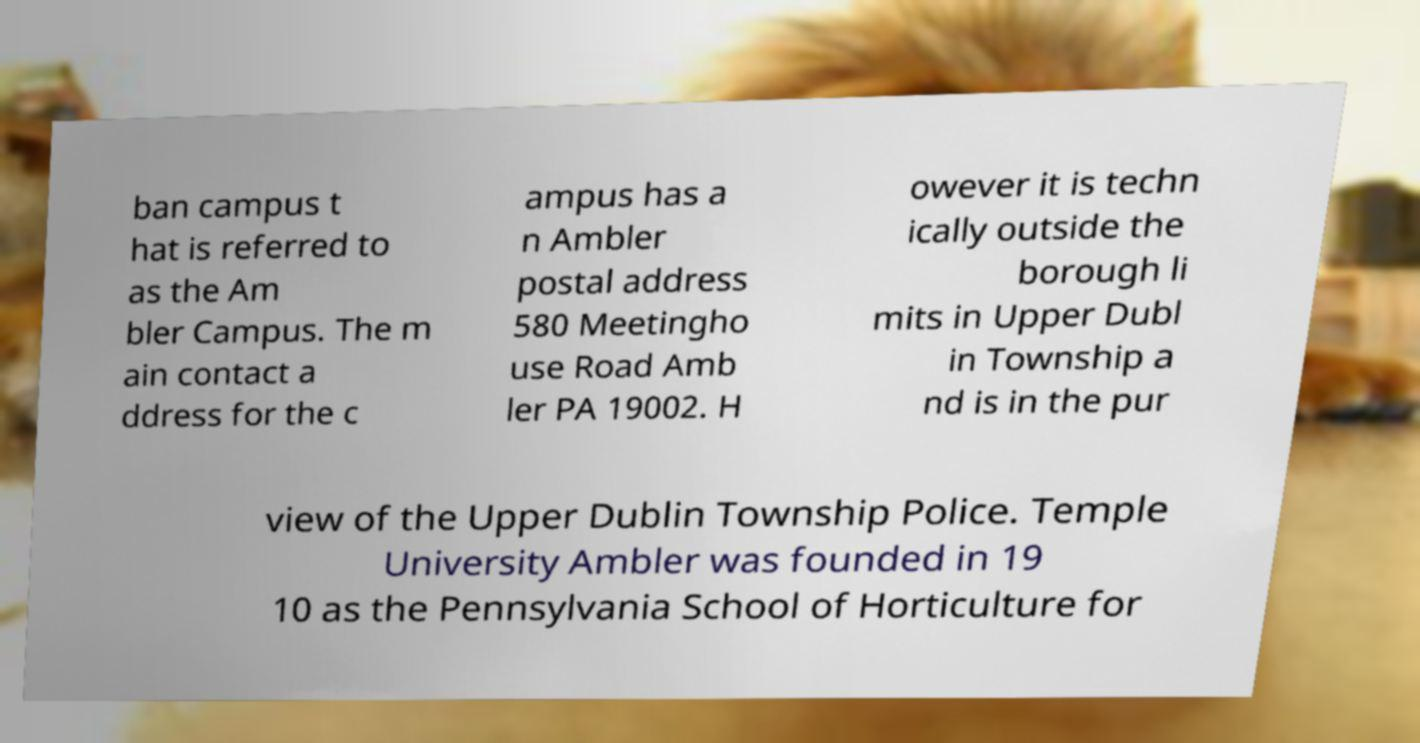Please identify and transcribe the text found in this image. ban campus t hat is referred to as the Am bler Campus. The m ain contact a ddress for the c ampus has a n Ambler postal address 580 Meetingho use Road Amb ler PA 19002. H owever it is techn ically outside the borough li mits in Upper Dubl in Township a nd is in the pur view of the Upper Dublin Township Police. Temple University Ambler was founded in 19 10 as the Pennsylvania School of Horticulture for 